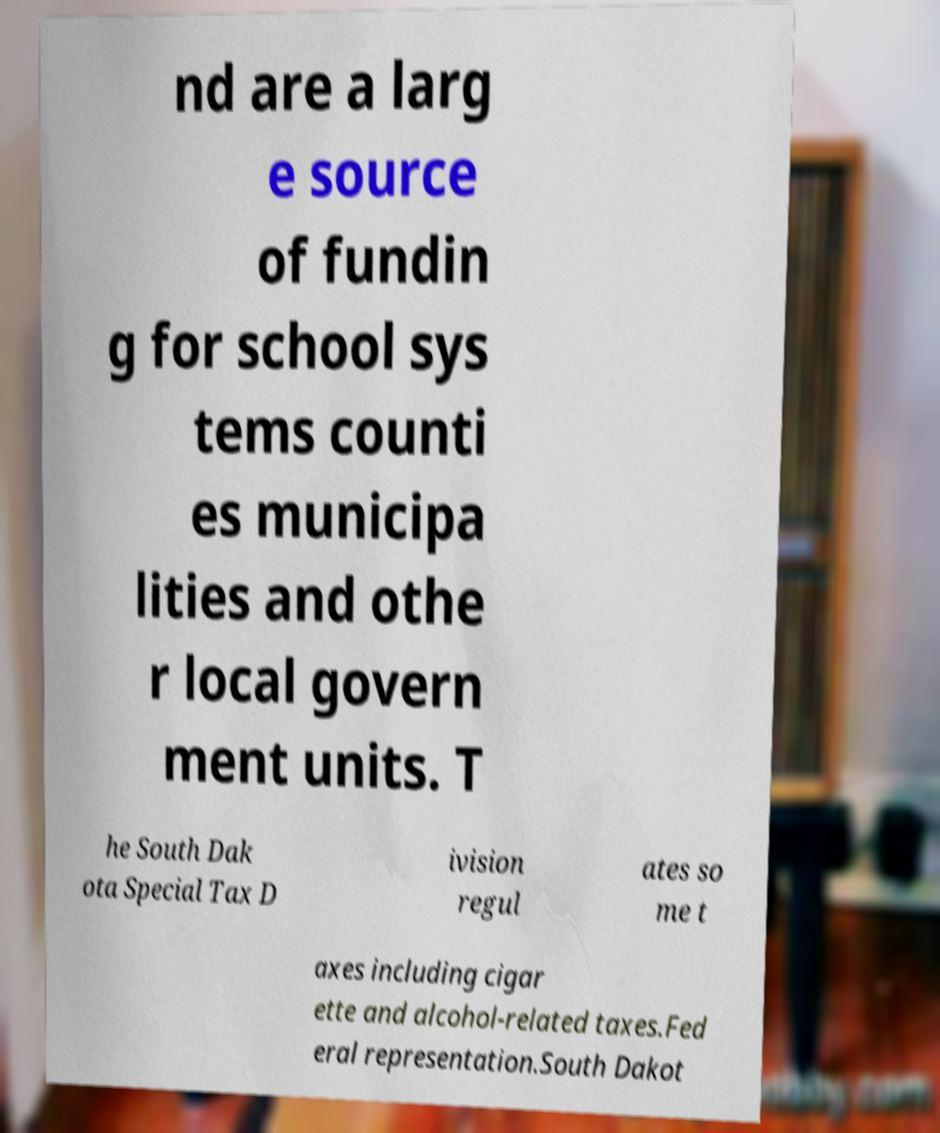Could you assist in decoding the text presented in this image and type it out clearly? nd are a larg e source of fundin g for school sys tems counti es municipa lities and othe r local govern ment units. T he South Dak ota Special Tax D ivision regul ates so me t axes including cigar ette and alcohol-related taxes.Fed eral representation.South Dakot 